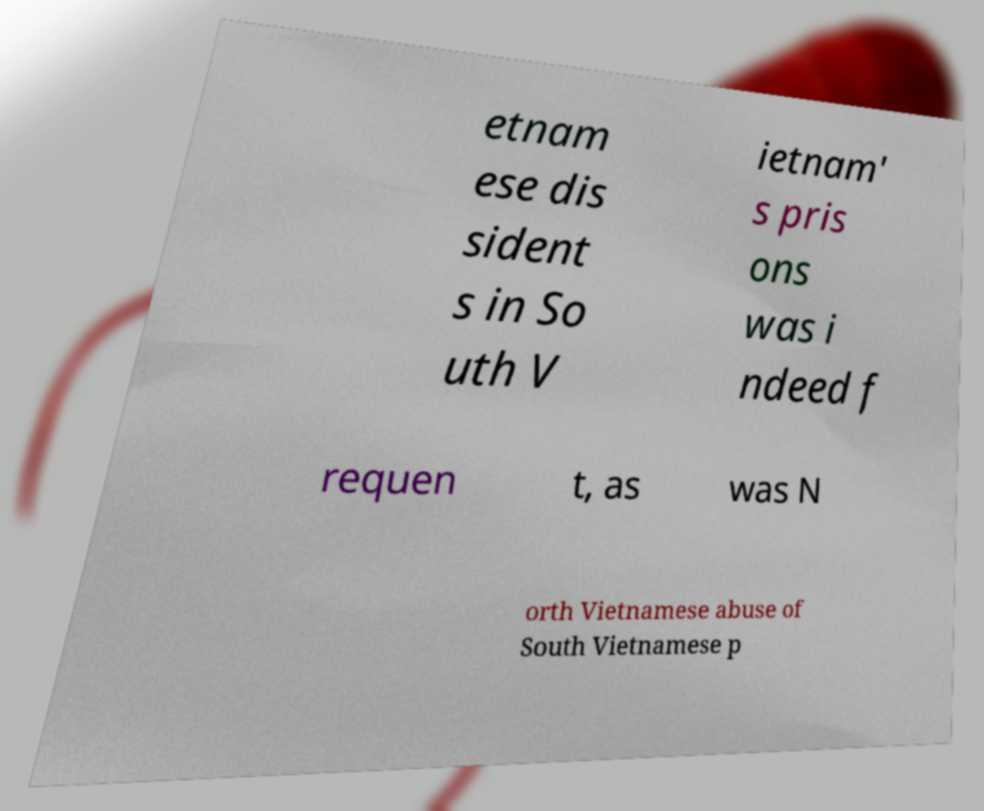Could you assist in decoding the text presented in this image and type it out clearly? etnam ese dis sident s in So uth V ietnam' s pris ons was i ndeed f requen t, as was N orth Vietnamese abuse of South Vietnamese p 